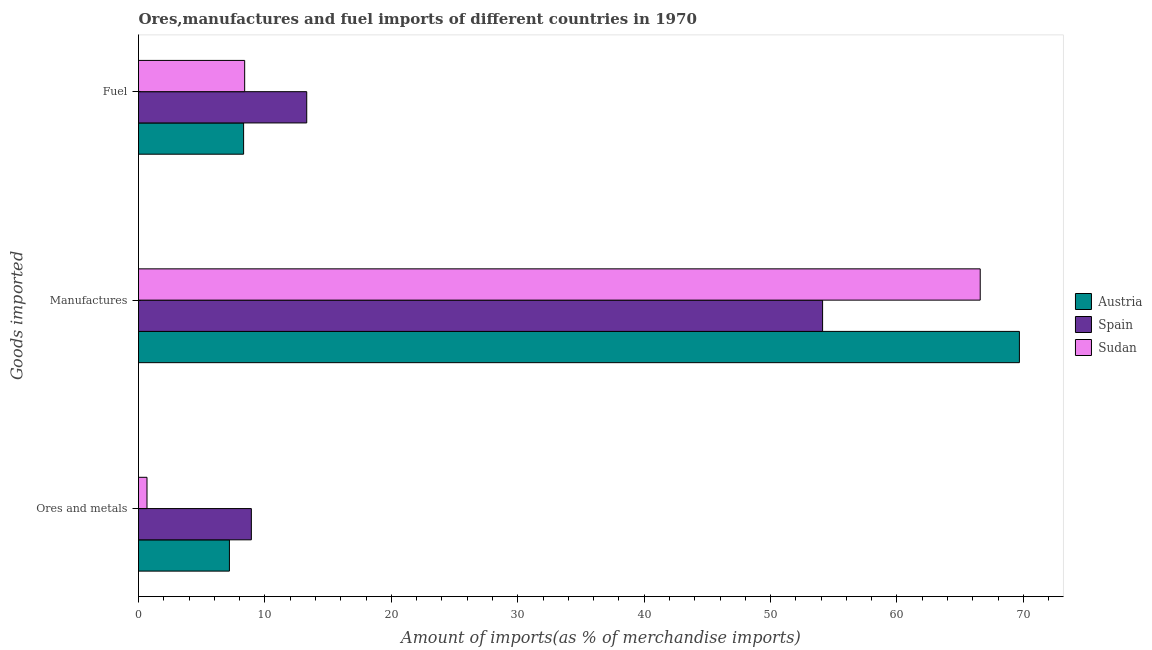How many different coloured bars are there?
Make the answer very short. 3. Are the number of bars per tick equal to the number of legend labels?
Provide a short and direct response. Yes. Are the number of bars on each tick of the Y-axis equal?
Offer a very short reply. Yes. What is the label of the 1st group of bars from the top?
Your answer should be very brief. Fuel. What is the percentage of manufactures imports in Sudan?
Your answer should be very brief. 66.58. Across all countries, what is the maximum percentage of fuel imports?
Provide a short and direct response. 13.31. Across all countries, what is the minimum percentage of manufactures imports?
Provide a short and direct response. 54.12. In which country was the percentage of manufactures imports maximum?
Provide a short and direct response. Austria. In which country was the percentage of ores and metals imports minimum?
Offer a very short reply. Sudan. What is the total percentage of ores and metals imports in the graph?
Make the answer very short. 16.79. What is the difference between the percentage of manufactures imports in Sudan and that in Spain?
Give a very brief answer. 12.47. What is the difference between the percentage of manufactures imports in Spain and the percentage of fuel imports in Austria?
Offer a terse response. 45.8. What is the average percentage of fuel imports per country?
Make the answer very short. 10.01. What is the difference between the percentage of ores and metals imports and percentage of manufactures imports in Sudan?
Offer a terse response. -65.91. In how many countries, is the percentage of ores and metals imports greater than 18 %?
Provide a succinct answer. 0. What is the ratio of the percentage of ores and metals imports in Austria to that in Sudan?
Offer a very short reply. 10.7. What is the difference between the highest and the second highest percentage of manufactures imports?
Keep it short and to the point. 3.1. What is the difference between the highest and the lowest percentage of ores and metals imports?
Your answer should be very brief. 8.26. In how many countries, is the percentage of fuel imports greater than the average percentage of fuel imports taken over all countries?
Offer a very short reply. 1. What does the 3rd bar from the bottom in Fuel represents?
Offer a very short reply. Sudan. Are all the bars in the graph horizontal?
Keep it short and to the point. Yes. How many countries are there in the graph?
Give a very brief answer. 3. Does the graph contain any zero values?
Offer a very short reply. No. Does the graph contain grids?
Offer a terse response. No. How many legend labels are there?
Keep it short and to the point. 3. How are the legend labels stacked?
Offer a very short reply. Vertical. What is the title of the graph?
Keep it short and to the point. Ores,manufactures and fuel imports of different countries in 1970. Does "Channel Islands" appear as one of the legend labels in the graph?
Offer a very short reply. No. What is the label or title of the X-axis?
Ensure brevity in your answer.  Amount of imports(as % of merchandise imports). What is the label or title of the Y-axis?
Provide a succinct answer. Goods imported. What is the Amount of imports(as % of merchandise imports) of Austria in Ores and metals?
Provide a short and direct response. 7.19. What is the Amount of imports(as % of merchandise imports) in Spain in Ores and metals?
Provide a short and direct response. 8.93. What is the Amount of imports(as % of merchandise imports) of Sudan in Ores and metals?
Your answer should be compact. 0.67. What is the Amount of imports(as % of merchandise imports) of Austria in Manufactures?
Offer a terse response. 69.68. What is the Amount of imports(as % of merchandise imports) of Spain in Manufactures?
Ensure brevity in your answer.  54.12. What is the Amount of imports(as % of merchandise imports) of Sudan in Manufactures?
Keep it short and to the point. 66.58. What is the Amount of imports(as % of merchandise imports) in Austria in Fuel?
Give a very brief answer. 8.31. What is the Amount of imports(as % of merchandise imports) of Spain in Fuel?
Offer a very short reply. 13.31. What is the Amount of imports(as % of merchandise imports) of Sudan in Fuel?
Give a very brief answer. 8.4. Across all Goods imported, what is the maximum Amount of imports(as % of merchandise imports) of Austria?
Give a very brief answer. 69.68. Across all Goods imported, what is the maximum Amount of imports(as % of merchandise imports) in Spain?
Ensure brevity in your answer.  54.12. Across all Goods imported, what is the maximum Amount of imports(as % of merchandise imports) in Sudan?
Your answer should be very brief. 66.58. Across all Goods imported, what is the minimum Amount of imports(as % of merchandise imports) in Austria?
Offer a terse response. 7.19. Across all Goods imported, what is the minimum Amount of imports(as % of merchandise imports) of Spain?
Give a very brief answer. 8.93. Across all Goods imported, what is the minimum Amount of imports(as % of merchandise imports) in Sudan?
Provide a succinct answer. 0.67. What is the total Amount of imports(as % of merchandise imports) of Austria in the graph?
Provide a succinct answer. 85.19. What is the total Amount of imports(as % of merchandise imports) in Spain in the graph?
Your answer should be compact. 76.35. What is the total Amount of imports(as % of merchandise imports) of Sudan in the graph?
Your answer should be very brief. 75.66. What is the difference between the Amount of imports(as % of merchandise imports) in Austria in Ores and metals and that in Manufactures?
Your answer should be very brief. -62.49. What is the difference between the Amount of imports(as % of merchandise imports) of Spain in Ores and metals and that in Manufactures?
Keep it short and to the point. -45.19. What is the difference between the Amount of imports(as % of merchandise imports) in Sudan in Ores and metals and that in Manufactures?
Your answer should be very brief. -65.91. What is the difference between the Amount of imports(as % of merchandise imports) of Austria in Ores and metals and that in Fuel?
Your answer should be very brief. -1.12. What is the difference between the Amount of imports(as % of merchandise imports) in Spain in Ores and metals and that in Fuel?
Offer a very short reply. -4.38. What is the difference between the Amount of imports(as % of merchandise imports) of Sudan in Ores and metals and that in Fuel?
Offer a very short reply. -7.73. What is the difference between the Amount of imports(as % of merchandise imports) of Austria in Manufactures and that in Fuel?
Offer a very short reply. 61.37. What is the difference between the Amount of imports(as % of merchandise imports) in Spain in Manufactures and that in Fuel?
Make the answer very short. 40.81. What is the difference between the Amount of imports(as % of merchandise imports) in Sudan in Manufactures and that in Fuel?
Offer a terse response. 58.19. What is the difference between the Amount of imports(as % of merchandise imports) in Austria in Ores and metals and the Amount of imports(as % of merchandise imports) in Spain in Manufactures?
Provide a succinct answer. -46.92. What is the difference between the Amount of imports(as % of merchandise imports) of Austria in Ores and metals and the Amount of imports(as % of merchandise imports) of Sudan in Manufactures?
Give a very brief answer. -59.39. What is the difference between the Amount of imports(as % of merchandise imports) in Spain in Ores and metals and the Amount of imports(as % of merchandise imports) in Sudan in Manufactures?
Offer a very short reply. -57.66. What is the difference between the Amount of imports(as % of merchandise imports) of Austria in Ores and metals and the Amount of imports(as % of merchandise imports) of Spain in Fuel?
Offer a terse response. -6.12. What is the difference between the Amount of imports(as % of merchandise imports) of Austria in Ores and metals and the Amount of imports(as % of merchandise imports) of Sudan in Fuel?
Provide a short and direct response. -1.21. What is the difference between the Amount of imports(as % of merchandise imports) of Spain in Ores and metals and the Amount of imports(as % of merchandise imports) of Sudan in Fuel?
Keep it short and to the point. 0.53. What is the difference between the Amount of imports(as % of merchandise imports) of Austria in Manufactures and the Amount of imports(as % of merchandise imports) of Spain in Fuel?
Make the answer very short. 56.38. What is the difference between the Amount of imports(as % of merchandise imports) in Austria in Manufactures and the Amount of imports(as % of merchandise imports) in Sudan in Fuel?
Offer a terse response. 61.29. What is the difference between the Amount of imports(as % of merchandise imports) in Spain in Manufactures and the Amount of imports(as % of merchandise imports) in Sudan in Fuel?
Your answer should be compact. 45.72. What is the average Amount of imports(as % of merchandise imports) in Austria per Goods imported?
Your response must be concise. 28.4. What is the average Amount of imports(as % of merchandise imports) of Spain per Goods imported?
Make the answer very short. 25.45. What is the average Amount of imports(as % of merchandise imports) in Sudan per Goods imported?
Your response must be concise. 25.22. What is the difference between the Amount of imports(as % of merchandise imports) in Austria and Amount of imports(as % of merchandise imports) in Spain in Ores and metals?
Your answer should be very brief. -1.74. What is the difference between the Amount of imports(as % of merchandise imports) of Austria and Amount of imports(as % of merchandise imports) of Sudan in Ores and metals?
Keep it short and to the point. 6.52. What is the difference between the Amount of imports(as % of merchandise imports) in Spain and Amount of imports(as % of merchandise imports) in Sudan in Ores and metals?
Ensure brevity in your answer.  8.26. What is the difference between the Amount of imports(as % of merchandise imports) in Austria and Amount of imports(as % of merchandise imports) in Spain in Manufactures?
Provide a succinct answer. 15.57. What is the difference between the Amount of imports(as % of merchandise imports) in Austria and Amount of imports(as % of merchandise imports) in Sudan in Manufactures?
Keep it short and to the point. 3.1. What is the difference between the Amount of imports(as % of merchandise imports) in Spain and Amount of imports(as % of merchandise imports) in Sudan in Manufactures?
Offer a terse response. -12.47. What is the difference between the Amount of imports(as % of merchandise imports) of Austria and Amount of imports(as % of merchandise imports) of Spain in Fuel?
Your response must be concise. -4.99. What is the difference between the Amount of imports(as % of merchandise imports) in Austria and Amount of imports(as % of merchandise imports) in Sudan in Fuel?
Ensure brevity in your answer.  -0.09. What is the difference between the Amount of imports(as % of merchandise imports) in Spain and Amount of imports(as % of merchandise imports) in Sudan in Fuel?
Offer a very short reply. 4.91. What is the ratio of the Amount of imports(as % of merchandise imports) of Austria in Ores and metals to that in Manufactures?
Make the answer very short. 0.1. What is the ratio of the Amount of imports(as % of merchandise imports) of Spain in Ores and metals to that in Manufactures?
Give a very brief answer. 0.17. What is the ratio of the Amount of imports(as % of merchandise imports) of Sudan in Ores and metals to that in Manufactures?
Keep it short and to the point. 0.01. What is the ratio of the Amount of imports(as % of merchandise imports) of Austria in Ores and metals to that in Fuel?
Keep it short and to the point. 0.86. What is the ratio of the Amount of imports(as % of merchandise imports) of Spain in Ores and metals to that in Fuel?
Offer a terse response. 0.67. What is the ratio of the Amount of imports(as % of merchandise imports) of Austria in Manufactures to that in Fuel?
Your response must be concise. 8.38. What is the ratio of the Amount of imports(as % of merchandise imports) of Spain in Manufactures to that in Fuel?
Ensure brevity in your answer.  4.07. What is the ratio of the Amount of imports(as % of merchandise imports) of Sudan in Manufactures to that in Fuel?
Make the answer very short. 7.93. What is the difference between the highest and the second highest Amount of imports(as % of merchandise imports) in Austria?
Make the answer very short. 61.37. What is the difference between the highest and the second highest Amount of imports(as % of merchandise imports) in Spain?
Your answer should be very brief. 40.81. What is the difference between the highest and the second highest Amount of imports(as % of merchandise imports) in Sudan?
Provide a succinct answer. 58.19. What is the difference between the highest and the lowest Amount of imports(as % of merchandise imports) in Austria?
Ensure brevity in your answer.  62.49. What is the difference between the highest and the lowest Amount of imports(as % of merchandise imports) in Spain?
Your response must be concise. 45.19. What is the difference between the highest and the lowest Amount of imports(as % of merchandise imports) of Sudan?
Offer a very short reply. 65.91. 